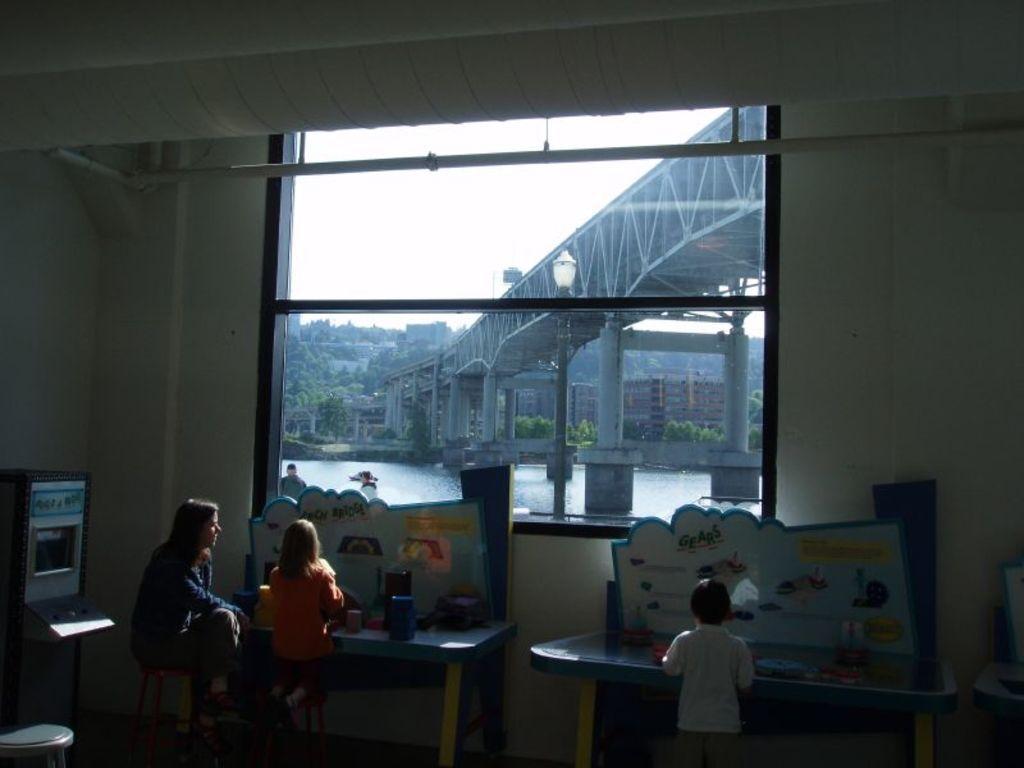Can you describe this image briefly? In this picture we can see few people, here we can see tables, boards, wall, window and some objects, through the window we can see a bridge, water, buildings, trees and the sky. 